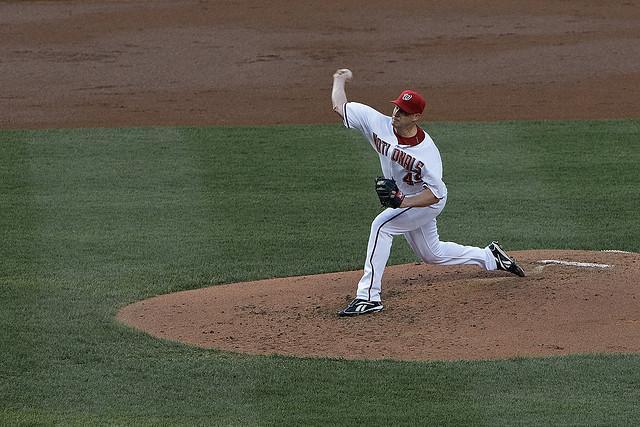How many people can be seen?
Give a very brief answer. 1. How many birds are standing in the water?
Give a very brief answer. 0. 